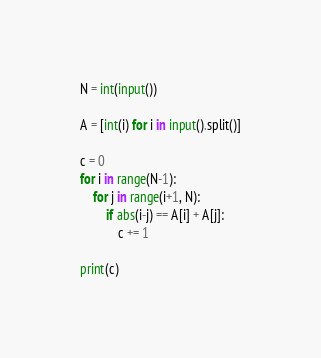<code> <loc_0><loc_0><loc_500><loc_500><_Python_>N = int(input())

A = [int(i) for i in input().split()]

c = 0
for i in range(N-1):
    for j in range(i+1, N):
        if abs(i-j) == A[i] + A[j]:
            c += 1
            
print(c)</code> 